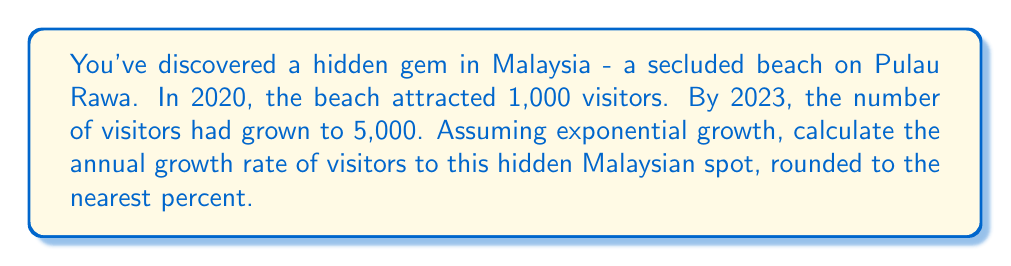Provide a solution to this math problem. Let's approach this step-by-step using the exponential growth formula:

1) The exponential growth formula is:
   $A = P(1 + r)^t$
   Where:
   $A$ = Final amount
   $P$ = Initial amount
   $r$ = Annual growth rate (in decimal form)
   $t$ = Time period (in years)

2) We know:
   $P = 1,000$ (visitors in 2020)
   $A = 5,000$ (visitors in 2023)
   $t = 3$ years (from 2020 to 2023)

3) Let's substitute these values into the formula:
   $5,000 = 1,000(1 + r)^3$

4) Divide both sides by 1,000:
   $5 = (1 + r)^3$

5) Take the cube root of both sides:
   $\sqrt[3]{5} = 1 + r$

6) Subtract 1 from both sides:
   $\sqrt[3]{5} - 1 = r$

7) Calculate:
   $r = \sqrt[3]{5} - 1 \approx 1.7100 - 1 = 0.7100$

8) Convert to percentage:
   $0.7100 \times 100 = 71\%$

Therefore, the annual growth rate is approximately 71%.
Answer: 71% 